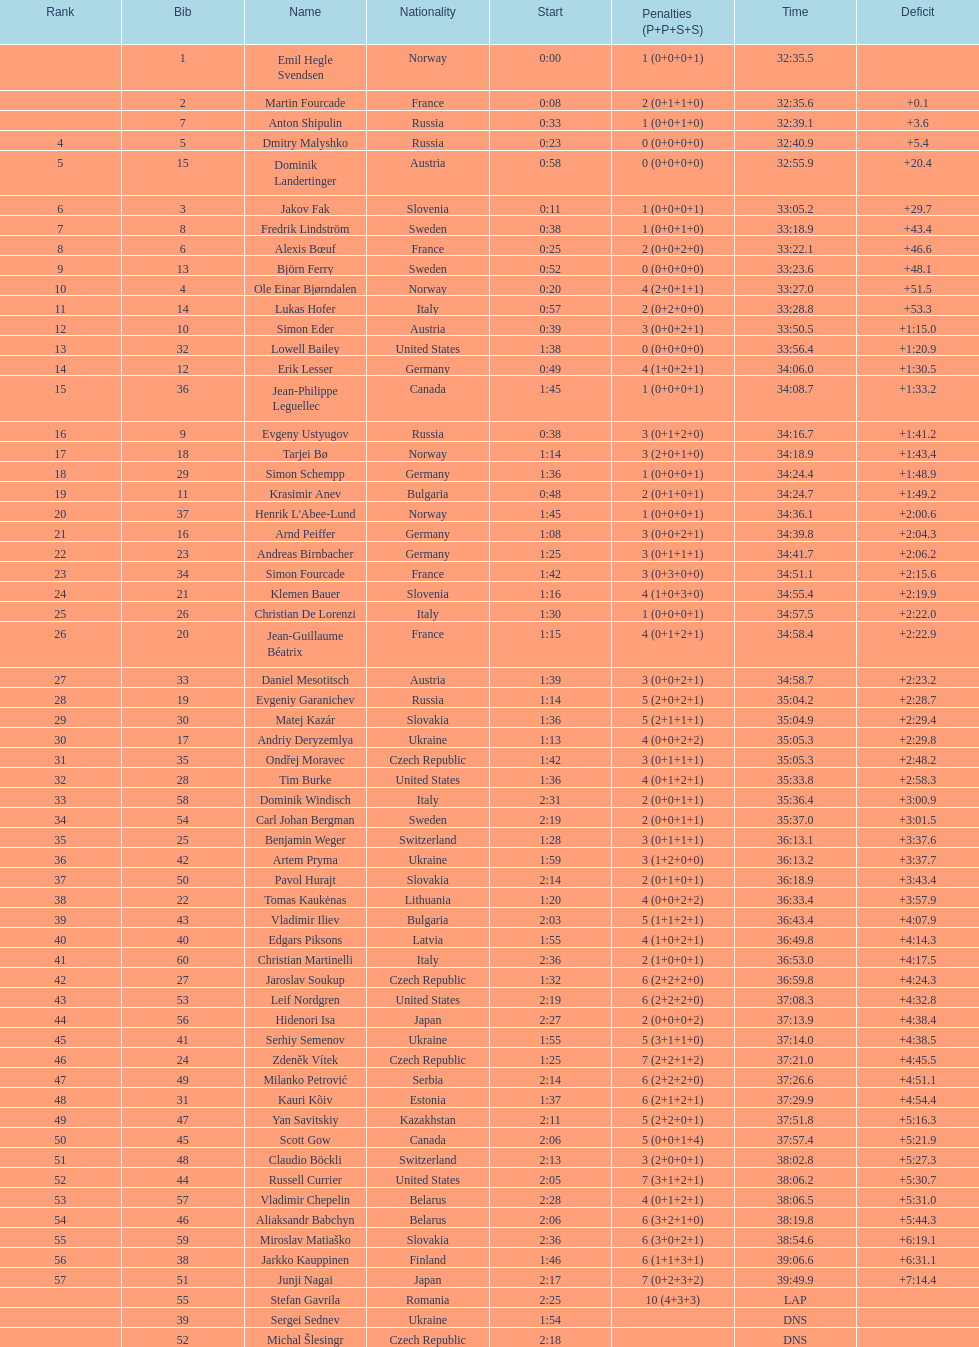Who holds the top position among swedish runners? Fredrik Lindström. 